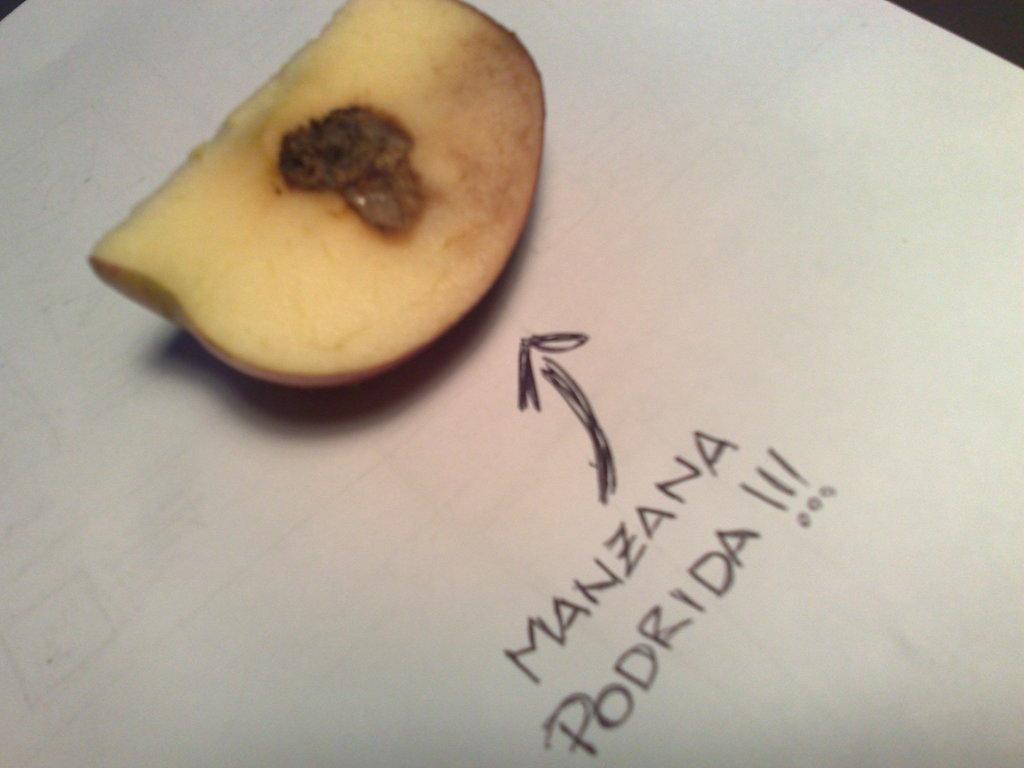Describe this image in one or two sentences. In the image there is an apple slice kept on a paper and there is some text written on the paper beside the apple. 